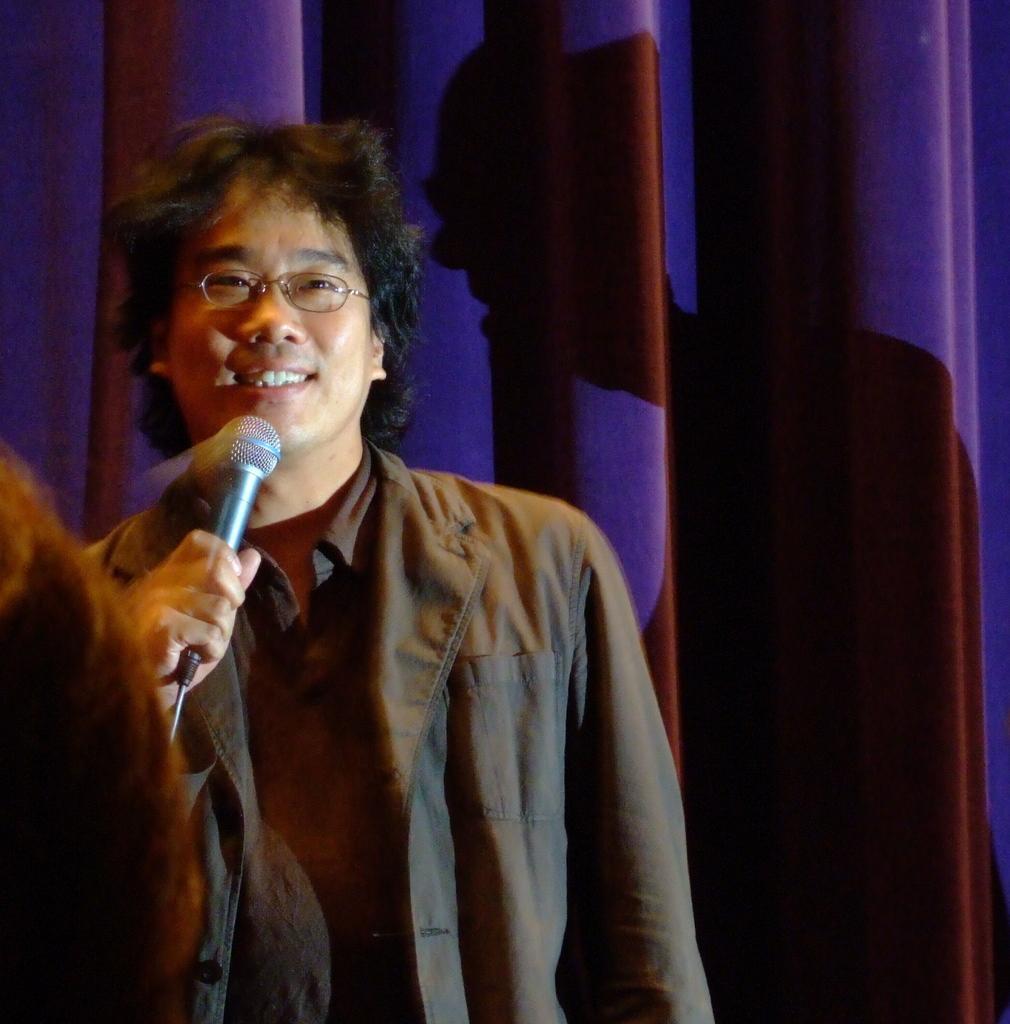How would you summarize this image in a sentence or two? In this image their is a man standing with a mic in his hand and smiling. At the background there a curtain. 